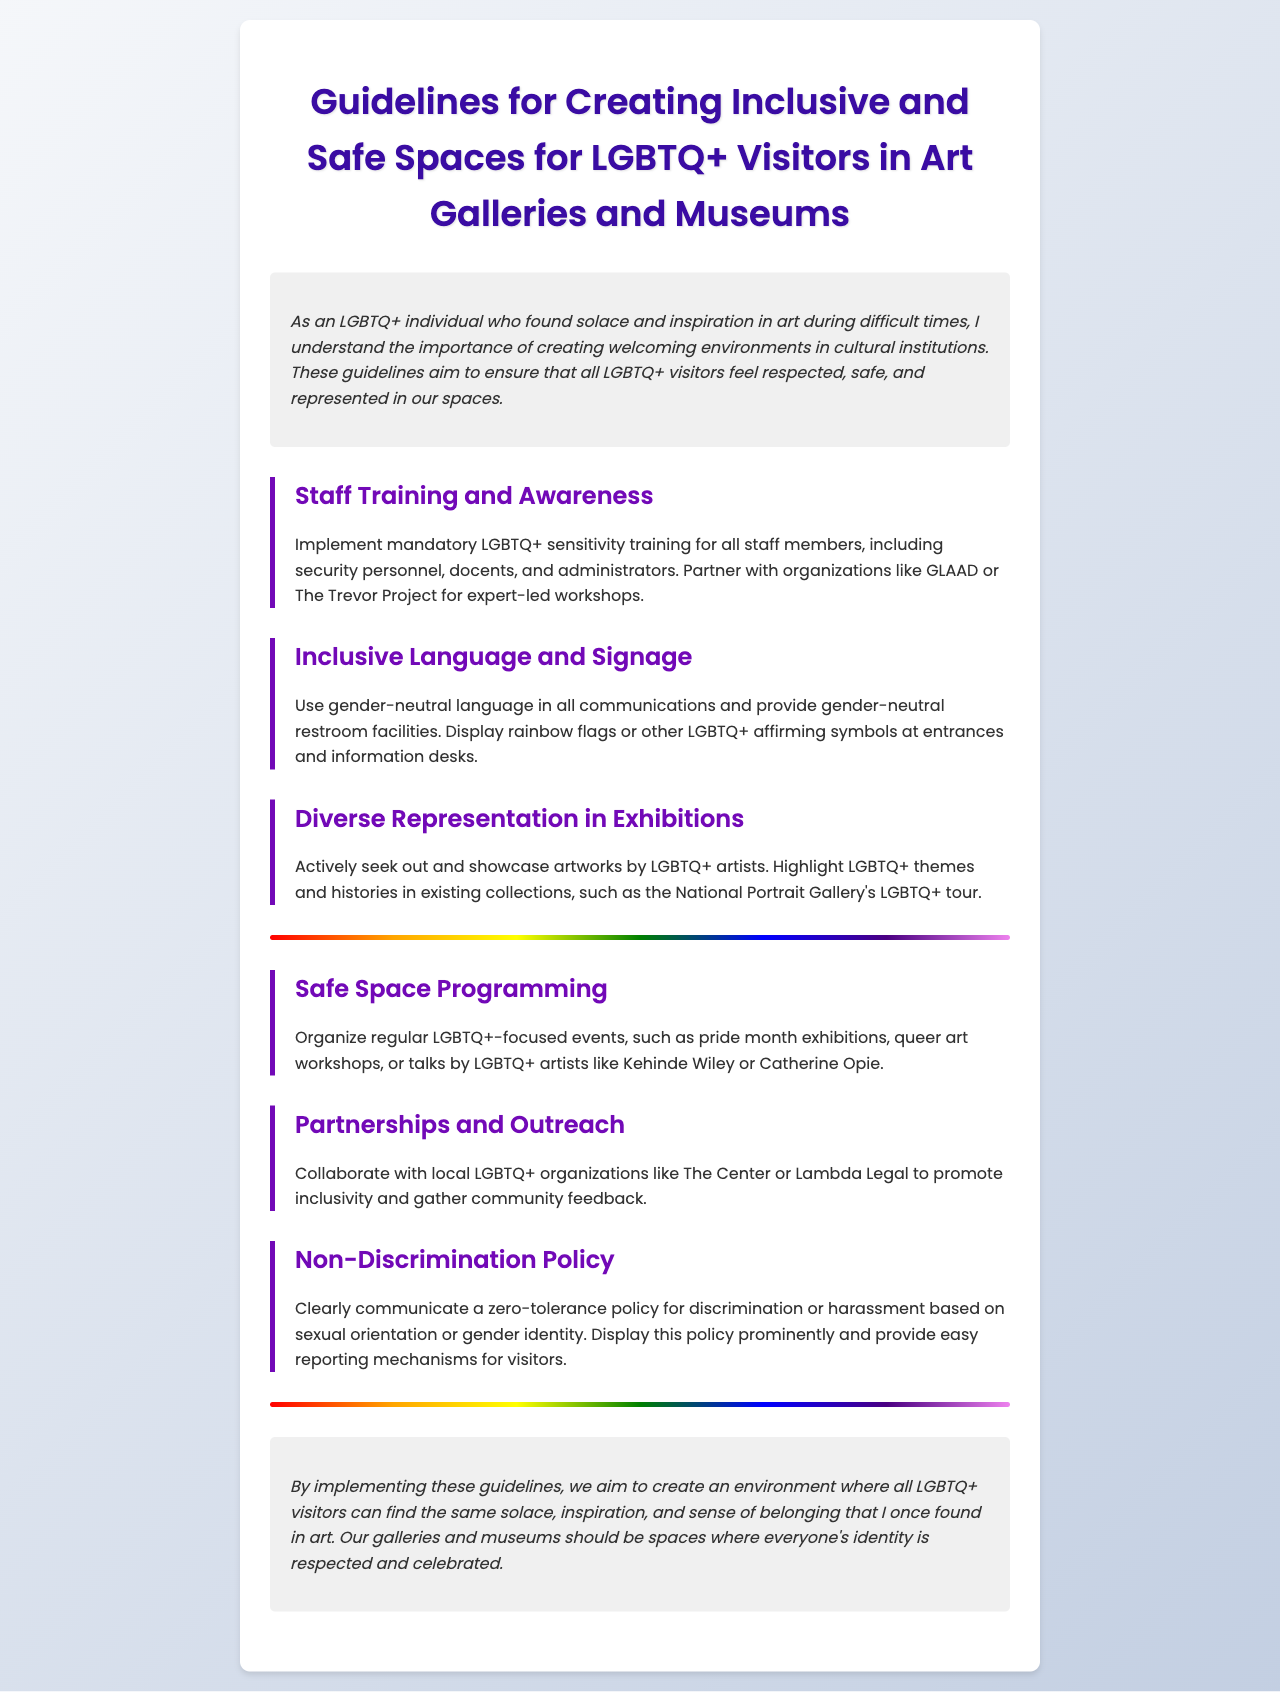What is the title of the document? The title of the document is given at the top of the rendered page.
Answer: Guidelines for Creating Inclusive and Safe Spaces for LGBTQ+ Visitors in Art Galleries and Museums What organization is recommended for training? The document mentions organizations that can provide expert-led workshops for staff training.
Answer: GLAAD or The Trevor Project What should be displayed at entrances? This is a specific symbol that indicates support for LGBTQ+ individuals.
Answer: Rainbow flags What type of events are suggested for programming? The document suggests regular events focusing on a specific community.
Answer: LGBTQ+-focused events What is the stated policy against discrimination? The document highlights a specific attitude towards discrimination based on sexual orientation or gender identity.
Answer: Zero-tolerance policy What should be included in all communications? This refers to the language that should be used in the galleries and museums.
Answer: Gender-neutral language What is one way to promote inclusivity? This involves a type of collaboration to gather community feedback.
Answer: Collaborate with local LGBTQ+ organizations Who does the document mention as artists for talks? This identifies notable artists suggested for events.
Answer: Kehinde Wiley or Catherine Opie 